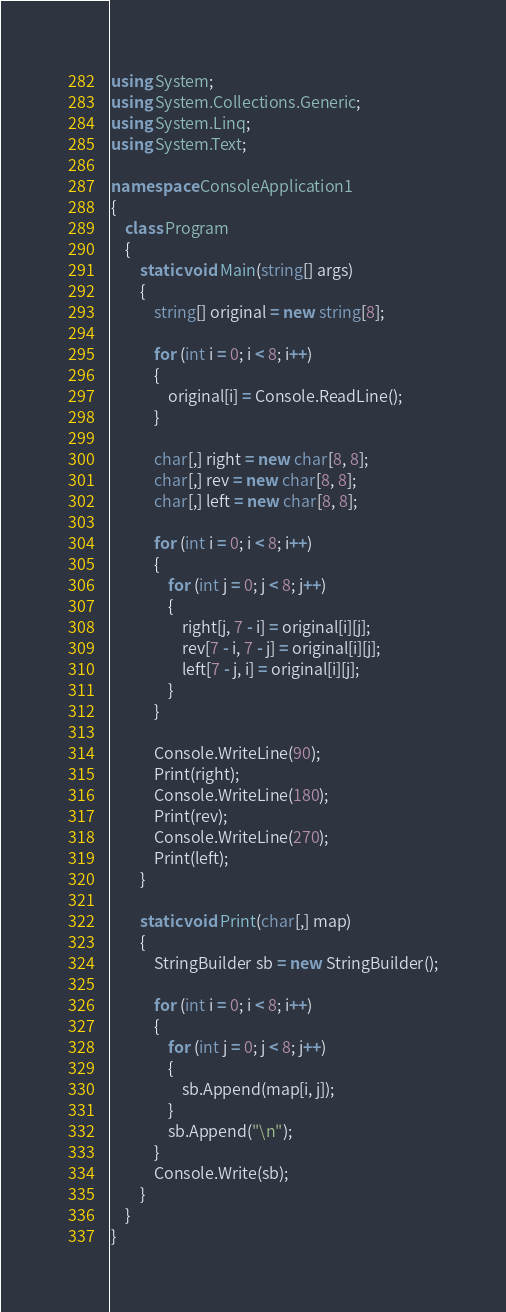<code> <loc_0><loc_0><loc_500><loc_500><_C#_>using System;
using System.Collections.Generic;
using System.Linq;
using System.Text;

namespace ConsoleApplication1
{
    class Program
    {
        static void Main(string[] args)
        {
            string[] original = new string[8];

            for (int i = 0; i < 8; i++)
            {
                original[i] = Console.ReadLine();
            }

            char[,] right = new char[8, 8];
            char[,] rev = new char[8, 8];
            char[,] left = new char[8, 8];

            for (int i = 0; i < 8; i++)
            {
                for (int j = 0; j < 8; j++)
                {
                    right[j, 7 - i] = original[i][j];
                    rev[7 - i, 7 - j] = original[i][j];
                    left[7 - j, i] = original[i][j];
                }
            }

            Console.WriteLine(90);
            Print(right);
            Console.WriteLine(180);
            Print(rev);
            Console.WriteLine(270);
            Print(left);
        }

        static void Print(char[,] map)
        {
            StringBuilder sb = new StringBuilder();

            for (int i = 0; i < 8; i++)
            {
                for (int j = 0; j < 8; j++)
                {
                    sb.Append(map[i, j]);
                }
                sb.Append("\n");
            }
            Console.Write(sb);
        }
    }
}</code> 